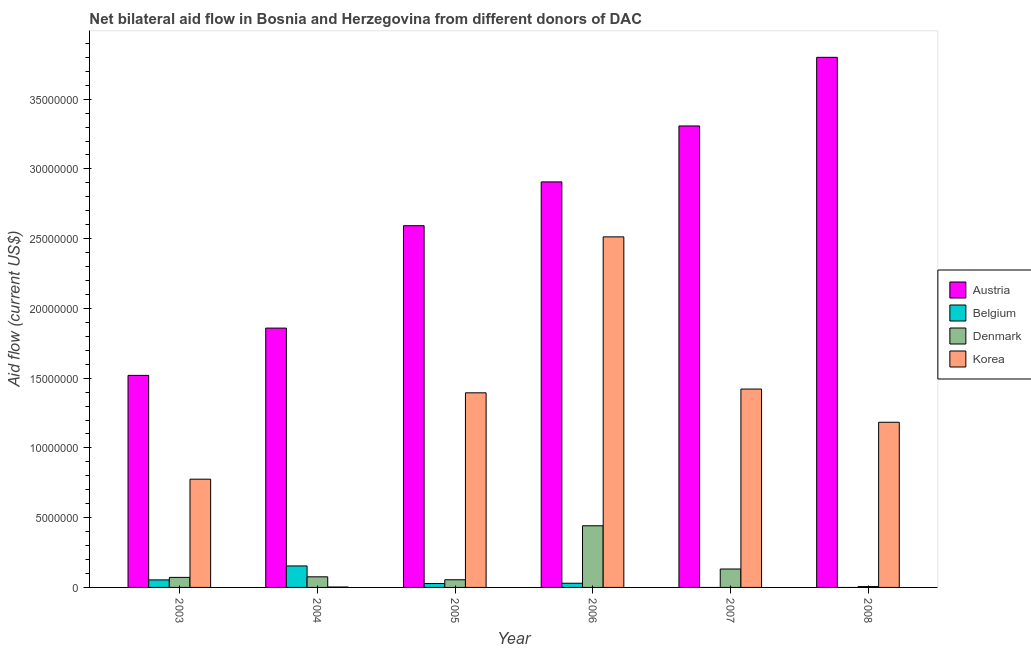How many groups of bars are there?
Make the answer very short. 6. How many bars are there on the 1st tick from the right?
Offer a terse response. 3. In how many cases, is the number of bars for a given year not equal to the number of legend labels?
Give a very brief answer. 2. What is the amount of aid given by belgium in 2005?
Your response must be concise. 2.80e+05. Across all years, what is the maximum amount of aid given by austria?
Ensure brevity in your answer.  3.80e+07. Across all years, what is the minimum amount of aid given by belgium?
Your answer should be very brief. 0. What is the total amount of aid given by korea in the graph?
Provide a succinct answer. 7.29e+07. What is the difference between the amount of aid given by belgium in 2003 and that in 2006?
Offer a terse response. 2.40e+05. What is the difference between the amount of aid given by belgium in 2005 and the amount of aid given by austria in 2004?
Your response must be concise. -1.26e+06. What is the average amount of aid given by belgium per year?
Your answer should be very brief. 4.43e+05. In the year 2006, what is the difference between the amount of aid given by korea and amount of aid given by denmark?
Give a very brief answer. 0. In how many years, is the amount of aid given by austria greater than 8000000 US$?
Make the answer very short. 6. What is the ratio of the amount of aid given by denmark in 2003 to that in 2005?
Keep it short and to the point. 1.31. What is the difference between the highest and the second highest amount of aid given by korea?
Give a very brief answer. 1.09e+07. What is the difference between the highest and the lowest amount of aid given by denmark?
Provide a short and direct response. 4.36e+06. Is it the case that in every year, the sum of the amount of aid given by denmark and amount of aid given by korea is greater than the sum of amount of aid given by austria and amount of aid given by belgium?
Provide a short and direct response. No. How many bars are there?
Offer a very short reply. 22. How many years are there in the graph?
Your response must be concise. 6. Does the graph contain any zero values?
Offer a very short reply. Yes. Does the graph contain grids?
Ensure brevity in your answer.  No. Where does the legend appear in the graph?
Offer a very short reply. Center right. How many legend labels are there?
Offer a terse response. 4. How are the legend labels stacked?
Make the answer very short. Vertical. What is the title of the graph?
Ensure brevity in your answer.  Net bilateral aid flow in Bosnia and Herzegovina from different donors of DAC. What is the label or title of the Y-axis?
Your answer should be very brief. Aid flow (current US$). What is the Aid flow (current US$) in Austria in 2003?
Keep it short and to the point. 1.52e+07. What is the Aid flow (current US$) of Belgium in 2003?
Your response must be concise. 5.40e+05. What is the Aid flow (current US$) in Denmark in 2003?
Provide a succinct answer. 7.20e+05. What is the Aid flow (current US$) of Korea in 2003?
Keep it short and to the point. 7.76e+06. What is the Aid flow (current US$) in Austria in 2004?
Offer a terse response. 1.86e+07. What is the Aid flow (current US$) in Belgium in 2004?
Give a very brief answer. 1.54e+06. What is the Aid flow (current US$) in Denmark in 2004?
Your answer should be compact. 7.60e+05. What is the Aid flow (current US$) of Korea in 2004?
Your response must be concise. 3.00e+04. What is the Aid flow (current US$) in Austria in 2005?
Provide a short and direct response. 2.59e+07. What is the Aid flow (current US$) in Denmark in 2005?
Keep it short and to the point. 5.50e+05. What is the Aid flow (current US$) of Korea in 2005?
Make the answer very short. 1.40e+07. What is the Aid flow (current US$) of Austria in 2006?
Offer a very short reply. 2.91e+07. What is the Aid flow (current US$) in Denmark in 2006?
Your response must be concise. 4.42e+06. What is the Aid flow (current US$) of Korea in 2006?
Offer a terse response. 2.51e+07. What is the Aid flow (current US$) in Austria in 2007?
Make the answer very short. 3.31e+07. What is the Aid flow (current US$) in Belgium in 2007?
Your answer should be very brief. 0. What is the Aid flow (current US$) in Denmark in 2007?
Offer a very short reply. 1.32e+06. What is the Aid flow (current US$) of Korea in 2007?
Your answer should be very brief. 1.42e+07. What is the Aid flow (current US$) of Austria in 2008?
Your answer should be very brief. 3.80e+07. What is the Aid flow (current US$) in Belgium in 2008?
Give a very brief answer. 0. What is the Aid flow (current US$) of Korea in 2008?
Keep it short and to the point. 1.18e+07. Across all years, what is the maximum Aid flow (current US$) of Austria?
Ensure brevity in your answer.  3.80e+07. Across all years, what is the maximum Aid flow (current US$) of Belgium?
Give a very brief answer. 1.54e+06. Across all years, what is the maximum Aid flow (current US$) of Denmark?
Keep it short and to the point. 4.42e+06. Across all years, what is the maximum Aid flow (current US$) of Korea?
Your answer should be compact. 2.51e+07. Across all years, what is the minimum Aid flow (current US$) in Austria?
Your response must be concise. 1.52e+07. Across all years, what is the minimum Aid flow (current US$) in Belgium?
Ensure brevity in your answer.  0. Across all years, what is the minimum Aid flow (current US$) in Denmark?
Provide a succinct answer. 6.00e+04. Across all years, what is the minimum Aid flow (current US$) in Korea?
Provide a short and direct response. 3.00e+04. What is the total Aid flow (current US$) in Austria in the graph?
Provide a succinct answer. 1.60e+08. What is the total Aid flow (current US$) in Belgium in the graph?
Give a very brief answer. 2.66e+06. What is the total Aid flow (current US$) in Denmark in the graph?
Provide a short and direct response. 7.83e+06. What is the total Aid flow (current US$) in Korea in the graph?
Your response must be concise. 7.29e+07. What is the difference between the Aid flow (current US$) of Austria in 2003 and that in 2004?
Make the answer very short. -3.39e+06. What is the difference between the Aid flow (current US$) of Korea in 2003 and that in 2004?
Ensure brevity in your answer.  7.73e+06. What is the difference between the Aid flow (current US$) of Austria in 2003 and that in 2005?
Offer a very short reply. -1.07e+07. What is the difference between the Aid flow (current US$) in Belgium in 2003 and that in 2005?
Offer a terse response. 2.60e+05. What is the difference between the Aid flow (current US$) in Korea in 2003 and that in 2005?
Keep it short and to the point. -6.19e+06. What is the difference between the Aid flow (current US$) of Austria in 2003 and that in 2006?
Offer a very short reply. -1.39e+07. What is the difference between the Aid flow (current US$) of Denmark in 2003 and that in 2006?
Your response must be concise. -3.70e+06. What is the difference between the Aid flow (current US$) of Korea in 2003 and that in 2006?
Provide a short and direct response. -1.74e+07. What is the difference between the Aid flow (current US$) of Austria in 2003 and that in 2007?
Your answer should be compact. -1.79e+07. What is the difference between the Aid flow (current US$) of Denmark in 2003 and that in 2007?
Your answer should be compact. -6.00e+05. What is the difference between the Aid flow (current US$) of Korea in 2003 and that in 2007?
Provide a short and direct response. -6.46e+06. What is the difference between the Aid flow (current US$) in Austria in 2003 and that in 2008?
Give a very brief answer. -2.28e+07. What is the difference between the Aid flow (current US$) of Denmark in 2003 and that in 2008?
Provide a succinct answer. 6.60e+05. What is the difference between the Aid flow (current US$) in Korea in 2003 and that in 2008?
Offer a terse response. -4.08e+06. What is the difference between the Aid flow (current US$) of Austria in 2004 and that in 2005?
Provide a short and direct response. -7.34e+06. What is the difference between the Aid flow (current US$) in Belgium in 2004 and that in 2005?
Ensure brevity in your answer.  1.26e+06. What is the difference between the Aid flow (current US$) of Denmark in 2004 and that in 2005?
Provide a short and direct response. 2.10e+05. What is the difference between the Aid flow (current US$) in Korea in 2004 and that in 2005?
Provide a succinct answer. -1.39e+07. What is the difference between the Aid flow (current US$) in Austria in 2004 and that in 2006?
Keep it short and to the point. -1.05e+07. What is the difference between the Aid flow (current US$) of Belgium in 2004 and that in 2006?
Ensure brevity in your answer.  1.24e+06. What is the difference between the Aid flow (current US$) of Denmark in 2004 and that in 2006?
Provide a short and direct response. -3.66e+06. What is the difference between the Aid flow (current US$) of Korea in 2004 and that in 2006?
Make the answer very short. -2.51e+07. What is the difference between the Aid flow (current US$) of Austria in 2004 and that in 2007?
Give a very brief answer. -1.45e+07. What is the difference between the Aid flow (current US$) of Denmark in 2004 and that in 2007?
Your response must be concise. -5.60e+05. What is the difference between the Aid flow (current US$) in Korea in 2004 and that in 2007?
Offer a very short reply. -1.42e+07. What is the difference between the Aid flow (current US$) in Austria in 2004 and that in 2008?
Offer a very short reply. -1.94e+07. What is the difference between the Aid flow (current US$) in Denmark in 2004 and that in 2008?
Ensure brevity in your answer.  7.00e+05. What is the difference between the Aid flow (current US$) of Korea in 2004 and that in 2008?
Make the answer very short. -1.18e+07. What is the difference between the Aid flow (current US$) in Austria in 2005 and that in 2006?
Your answer should be compact. -3.14e+06. What is the difference between the Aid flow (current US$) of Belgium in 2005 and that in 2006?
Give a very brief answer. -2.00e+04. What is the difference between the Aid flow (current US$) of Denmark in 2005 and that in 2006?
Offer a very short reply. -3.87e+06. What is the difference between the Aid flow (current US$) of Korea in 2005 and that in 2006?
Offer a terse response. -1.12e+07. What is the difference between the Aid flow (current US$) of Austria in 2005 and that in 2007?
Your response must be concise. -7.15e+06. What is the difference between the Aid flow (current US$) of Denmark in 2005 and that in 2007?
Ensure brevity in your answer.  -7.70e+05. What is the difference between the Aid flow (current US$) of Korea in 2005 and that in 2007?
Provide a succinct answer. -2.70e+05. What is the difference between the Aid flow (current US$) in Austria in 2005 and that in 2008?
Offer a very short reply. -1.21e+07. What is the difference between the Aid flow (current US$) in Denmark in 2005 and that in 2008?
Ensure brevity in your answer.  4.90e+05. What is the difference between the Aid flow (current US$) in Korea in 2005 and that in 2008?
Give a very brief answer. 2.11e+06. What is the difference between the Aid flow (current US$) of Austria in 2006 and that in 2007?
Your answer should be compact. -4.01e+06. What is the difference between the Aid flow (current US$) in Denmark in 2006 and that in 2007?
Offer a terse response. 3.10e+06. What is the difference between the Aid flow (current US$) in Korea in 2006 and that in 2007?
Keep it short and to the point. 1.09e+07. What is the difference between the Aid flow (current US$) in Austria in 2006 and that in 2008?
Your response must be concise. -8.93e+06. What is the difference between the Aid flow (current US$) in Denmark in 2006 and that in 2008?
Offer a terse response. 4.36e+06. What is the difference between the Aid flow (current US$) in Korea in 2006 and that in 2008?
Ensure brevity in your answer.  1.33e+07. What is the difference between the Aid flow (current US$) of Austria in 2007 and that in 2008?
Offer a terse response. -4.92e+06. What is the difference between the Aid flow (current US$) in Denmark in 2007 and that in 2008?
Provide a succinct answer. 1.26e+06. What is the difference between the Aid flow (current US$) in Korea in 2007 and that in 2008?
Your answer should be compact. 2.38e+06. What is the difference between the Aid flow (current US$) in Austria in 2003 and the Aid flow (current US$) in Belgium in 2004?
Your answer should be compact. 1.37e+07. What is the difference between the Aid flow (current US$) in Austria in 2003 and the Aid flow (current US$) in Denmark in 2004?
Ensure brevity in your answer.  1.44e+07. What is the difference between the Aid flow (current US$) of Austria in 2003 and the Aid flow (current US$) of Korea in 2004?
Offer a terse response. 1.52e+07. What is the difference between the Aid flow (current US$) in Belgium in 2003 and the Aid flow (current US$) in Korea in 2004?
Give a very brief answer. 5.10e+05. What is the difference between the Aid flow (current US$) of Denmark in 2003 and the Aid flow (current US$) of Korea in 2004?
Make the answer very short. 6.90e+05. What is the difference between the Aid flow (current US$) of Austria in 2003 and the Aid flow (current US$) of Belgium in 2005?
Ensure brevity in your answer.  1.49e+07. What is the difference between the Aid flow (current US$) in Austria in 2003 and the Aid flow (current US$) in Denmark in 2005?
Keep it short and to the point. 1.46e+07. What is the difference between the Aid flow (current US$) of Austria in 2003 and the Aid flow (current US$) of Korea in 2005?
Provide a short and direct response. 1.25e+06. What is the difference between the Aid flow (current US$) of Belgium in 2003 and the Aid flow (current US$) of Denmark in 2005?
Give a very brief answer. -10000. What is the difference between the Aid flow (current US$) in Belgium in 2003 and the Aid flow (current US$) in Korea in 2005?
Give a very brief answer. -1.34e+07. What is the difference between the Aid flow (current US$) in Denmark in 2003 and the Aid flow (current US$) in Korea in 2005?
Offer a terse response. -1.32e+07. What is the difference between the Aid flow (current US$) in Austria in 2003 and the Aid flow (current US$) in Belgium in 2006?
Keep it short and to the point. 1.49e+07. What is the difference between the Aid flow (current US$) in Austria in 2003 and the Aid flow (current US$) in Denmark in 2006?
Make the answer very short. 1.08e+07. What is the difference between the Aid flow (current US$) in Austria in 2003 and the Aid flow (current US$) in Korea in 2006?
Offer a terse response. -9.93e+06. What is the difference between the Aid flow (current US$) of Belgium in 2003 and the Aid flow (current US$) of Denmark in 2006?
Provide a succinct answer. -3.88e+06. What is the difference between the Aid flow (current US$) of Belgium in 2003 and the Aid flow (current US$) of Korea in 2006?
Make the answer very short. -2.46e+07. What is the difference between the Aid flow (current US$) of Denmark in 2003 and the Aid flow (current US$) of Korea in 2006?
Your answer should be very brief. -2.44e+07. What is the difference between the Aid flow (current US$) of Austria in 2003 and the Aid flow (current US$) of Denmark in 2007?
Provide a succinct answer. 1.39e+07. What is the difference between the Aid flow (current US$) in Austria in 2003 and the Aid flow (current US$) in Korea in 2007?
Give a very brief answer. 9.80e+05. What is the difference between the Aid flow (current US$) in Belgium in 2003 and the Aid flow (current US$) in Denmark in 2007?
Your answer should be very brief. -7.80e+05. What is the difference between the Aid flow (current US$) of Belgium in 2003 and the Aid flow (current US$) of Korea in 2007?
Your response must be concise. -1.37e+07. What is the difference between the Aid flow (current US$) of Denmark in 2003 and the Aid flow (current US$) of Korea in 2007?
Offer a very short reply. -1.35e+07. What is the difference between the Aid flow (current US$) in Austria in 2003 and the Aid flow (current US$) in Denmark in 2008?
Offer a terse response. 1.51e+07. What is the difference between the Aid flow (current US$) of Austria in 2003 and the Aid flow (current US$) of Korea in 2008?
Give a very brief answer. 3.36e+06. What is the difference between the Aid flow (current US$) of Belgium in 2003 and the Aid flow (current US$) of Denmark in 2008?
Provide a succinct answer. 4.80e+05. What is the difference between the Aid flow (current US$) in Belgium in 2003 and the Aid flow (current US$) in Korea in 2008?
Make the answer very short. -1.13e+07. What is the difference between the Aid flow (current US$) in Denmark in 2003 and the Aid flow (current US$) in Korea in 2008?
Provide a succinct answer. -1.11e+07. What is the difference between the Aid flow (current US$) in Austria in 2004 and the Aid flow (current US$) in Belgium in 2005?
Give a very brief answer. 1.83e+07. What is the difference between the Aid flow (current US$) in Austria in 2004 and the Aid flow (current US$) in Denmark in 2005?
Ensure brevity in your answer.  1.80e+07. What is the difference between the Aid flow (current US$) of Austria in 2004 and the Aid flow (current US$) of Korea in 2005?
Give a very brief answer. 4.64e+06. What is the difference between the Aid flow (current US$) in Belgium in 2004 and the Aid flow (current US$) in Denmark in 2005?
Offer a very short reply. 9.90e+05. What is the difference between the Aid flow (current US$) in Belgium in 2004 and the Aid flow (current US$) in Korea in 2005?
Ensure brevity in your answer.  -1.24e+07. What is the difference between the Aid flow (current US$) in Denmark in 2004 and the Aid flow (current US$) in Korea in 2005?
Give a very brief answer. -1.32e+07. What is the difference between the Aid flow (current US$) in Austria in 2004 and the Aid flow (current US$) in Belgium in 2006?
Offer a terse response. 1.83e+07. What is the difference between the Aid flow (current US$) in Austria in 2004 and the Aid flow (current US$) in Denmark in 2006?
Ensure brevity in your answer.  1.42e+07. What is the difference between the Aid flow (current US$) of Austria in 2004 and the Aid flow (current US$) of Korea in 2006?
Keep it short and to the point. -6.54e+06. What is the difference between the Aid flow (current US$) of Belgium in 2004 and the Aid flow (current US$) of Denmark in 2006?
Provide a short and direct response. -2.88e+06. What is the difference between the Aid flow (current US$) of Belgium in 2004 and the Aid flow (current US$) of Korea in 2006?
Make the answer very short. -2.36e+07. What is the difference between the Aid flow (current US$) of Denmark in 2004 and the Aid flow (current US$) of Korea in 2006?
Keep it short and to the point. -2.44e+07. What is the difference between the Aid flow (current US$) in Austria in 2004 and the Aid flow (current US$) in Denmark in 2007?
Your answer should be very brief. 1.73e+07. What is the difference between the Aid flow (current US$) of Austria in 2004 and the Aid flow (current US$) of Korea in 2007?
Offer a very short reply. 4.37e+06. What is the difference between the Aid flow (current US$) of Belgium in 2004 and the Aid flow (current US$) of Korea in 2007?
Make the answer very short. -1.27e+07. What is the difference between the Aid flow (current US$) of Denmark in 2004 and the Aid flow (current US$) of Korea in 2007?
Offer a very short reply. -1.35e+07. What is the difference between the Aid flow (current US$) of Austria in 2004 and the Aid flow (current US$) of Denmark in 2008?
Give a very brief answer. 1.85e+07. What is the difference between the Aid flow (current US$) of Austria in 2004 and the Aid flow (current US$) of Korea in 2008?
Keep it short and to the point. 6.75e+06. What is the difference between the Aid flow (current US$) of Belgium in 2004 and the Aid flow (current US$) of Denmark in 2008?
Provide a succinct answer. 1.48e+06. What is the difference between the Aid flow (current US$) in Belgium in 2004 and the Aid flow (current US$) in Korea in 2008?
Offer a terse response. -1.03e+07. What is the difference between the Aid flow (current US$) in Denmark in 2004 and the Aid flow (current US$) in Korea in 2008?
Your response must be concise. -1.11e+07. What is the difference between the Aid flow (current US$) of Austria in 2005 and the Aid flow (current US$) of Belgium in 2006?
Ensure brevity in your answer.  2.56e+07. What is the difference between the Aid flow (current US$) of Austria in 2005 and the Aid flow (current US$) of Denmark in 2006?
Your response must be concise. 2.15e+07. What is the difference between the Aid flow (current US$) of Belgium in 2005 and the Aid flow (current US$) of Denmark in 2006?
Make the answer very short. -4.14e+06. What is the difference between the Aid flow (current US$) in Belgium in 2005 and the Aid flow (current US$) in Korea in 2006?
Offer a very short reply. -2.48e+07. What is the difference between the Aid flow (current US$) of Denmark in 2005 and the Aid flow (current US$) of Korea in 2006?
Provide a succinct answer. -2.46e+07. What is the difference between the Aid flow (current US$) in Austria in 2005 and the Aid flow (current US$) in Denmark in 2007?
Keep it short and to the point. 2.46e+07. What is the difference between the Aid flow (current US$) of Austria in 2005 and the Aid flow (current US$) of Korea in 2007?
Your answer should be very brief. 1.17e+07. What is the difference between the Aid flow (current US$) in Belgium in 2005 and the Aid flow (current US$) in Denmark in 2007?
Your answer should be compact. -1.04e+06. What is the difference between the Aid flow (current US$) in Belgium in 2005 and the Aid flow (current US$) in Korea in 2007?
Offer a terse response. -1.39e+07. What is the difference between the Aid flow (current US$) in Denmark in 2005 and the Aid flow (current US$) in Korea in 2007?
Provide a succinct answer. -1.37e+07. What is the difference between the Aid flow (current US$) of Austria in 2005 and the Aid flow (current US$) of Denmark in 2008?
Offer a very short reply. 2.59e+07. What is the difference between the Aid flow (current US$) in Austria in 2005 and the Aid flow (current US$) in Korea in 2008?
Offer a very short reply. 1.41e+07. What is the difference between the Aid flow (current US$) in Belgium in 2005 and the Aid flow (current US$) in Denmark in 2008?
Provide a succinct answer. 2.20e+05. What is the difference between the Aid flow (current US$) of Belgium in 2005 and the Aid flow (current US$) of Korea in 2008?
Your response must be concise. -1.16e+07. What is the difference between the Aid flow (current US$) in Denmark in 2005 and the Aid flow (current US$) in Korea in 2008?
Keep it short and to the point. -1.13e+07. What is the difference between the Aid flow (current US$) of Austria in 2006 and the Aid flow (current US$) of Denmark in 2007?
Make the answer very short. 2.78e+07. What is the difference between the Aid flow (current US$) in Austria in 2006 and the Aid flow (current US$) in Korea in 2007?
Your answer should be very brief. 1.48e+07. What is the difference between the Aid flow (current US$) of Belgium in 2006 and the Aid flow (current US$) of Denmark in 2007?
Offer a terse response. -1.02e+06. What is the difference between the Aid flow (current US$) in Belgium in 2006 and the Aid flow (current US$) in Korea in 2007?
Your answer should be compact. -1.39e+07. What is the difference between the Aid flow (current US$) in Denmark in 2006 and the Aid flow (current US$) in Korea in 2007?
Keep it short and to the point. -9.80e+06. What is the difference between the Aid flow (current US$) in Austria in 2006 and the Aid flow (current US$) in Denmark in 2008?
Offer a terse response. 2.90e+07. What is the difference between the Aid flow (current US$) of Austria in 2006 and the Aid flow (current US$) of Korea in 2008?
Ensure brevity in your answer.  1.72e+07. What is the difference between the Aid flow (current US$) of Belgium in 2006 and the Aid flow (current US$) of Korea in 2008?
Offer a terse response. -1.15e+07. What is the difference between the Aid flow (current US$) of Denmark in 2006 and the Aid flow (current US$) of Korea in 2008?
Offer a very short reply. -7.42e+06. What is the difference between the Aid flow (current US$) in Austria in 2007 and the Aid flow (current US$) in Denmark in 2008?
Keep it short and to the point. 3.30e+07. What is the difference between the Aid flow (current US$) in Austria in 2007 and the Aid flow (current US$) in Korea in 2008?
Provide a succinct answer. 2.12e+07. What is the difference between the Aid flow (current US$) of Denmark in 2007 and the Aid flow (current US$) of Korea in 2008?
Give a very brief answer. -1.05e+07. What is the average Aid flow (current US$) in Austria per year?
Offer a terse response. 2.66e+07. What is the average Aid flow (current US$) of Belgium per year?
Provide a succinct answer. 4.43e+05. What is the average Aid flow (current US$) of Denmark per year?
Your answer should be very brief. 1.30e+06. What is the average Aid flow (current US$) of Korea per year?
Your answer should be very brief. 1.22e+07. In the year 2003, what is the difference between the Aid flow (current US$) in Austria and Aid flow (current US$) in Belgium?
Your answer should be very brief. 1.47e+07. In the year 2003, what is the difference between the Aid flow (current US$) of Austria and Aid flow (current US$) of Denmark?
Provide a short and direct response. 1.45e+07. In the year 2003, what is the difference between the Aid flow (current US$) of Austria and Aid flow (current US$) of Korea?
Provide a succinct answer. 7.44e+06. In the year 2003, what is the difference between the Aid flow (current US$) of Belgium and Aid flow (current US$) of Korea?
Offer a terse response. -7.22e+06. In the year 2003, what is the difference between the Aid flow (current US$) in Denmark and Aid flow (current US$) in Korea?
Your response must be concise. -7.04e+06. In the year 2004, what is the difference between the Aid flow (current US$) of Austria and Aid flow (current US$) of Belgium?
Ensure brevity in your answer.  1.70e+07. In the year 2004, what is the difference between the Aid flow (current US$) of Austria and Aid flow (current US$) of Denmark?
Offer a terse response. 1.78e+07. In the year 2004, what is the difference between the Aid flow (current US$) in Austria and Aid flow (current US$) in Korea?
Your answer should be compact. 1.86e+07. In the year 2004, what is the difference between the Aid flow (current US$) in Belgium and Aid flow (current US$) in Denmark?
Offer a terse response. 7.80e+05. In the year 2004, what is the difference between the Aid flow (current US$) in Belgium and Aid flow (current US$) in Korea?
Ensure brevity in your answer.  1.51e+06. In the year 2004, what is the difference between the Aid flow (current US$) of Denmark and Aid flow (current US$) of Korea?
Ensure brevity in your answer.  7.30e+05. In the year 2005, what is the difference between the Aid flow (current US$) of Austria and Aid flow (current US$) of Belgium?
Offer a terse response. 2.56e+07. In the year 2005, what is the difference between the Aid flow (current US$) in Austria and Aid flow (current US$) in Denmark?
Your answer should be compact. 2.54e+07. In the year 2005, what is the difference between the Aid flow (current US$) of Austria and Aid flow (current US$) of Korea?
Your response must be concise. 1.20e+07. In the year 2005, what is the difference between the Aid flow (current US$) in Belgium and Aid flow (current US$) in Denmark?
Provide a succinct answer. -2.70e+05. In the year 2005, what is the difference between the Aid flow (current US$) of Belgium and Aid flow (current US$) of Korea?
Keep it short and to the point. -1.37e+07. In the year 2005, what is the difference between the Aid flow (current US$) of Denmark and Aid flow (current US$) of Korea?
Your answer should be very brief. -1.34e+07. In the year 2006, what is the difference between the Aid flow (current US$) of Austria and Aid flow (current US$) of Belgium?
Your answer should be compact. 2.88e+07. In the year 2006, what is the difference between the Aid flow (current US$) of Austria and Aid flow (current US$) of Denmark?
Make the answer very short. 2.46e+07. In the year 2006, what is the difference between the Aid flow (current US$) in Austria and Aid flow (current US$) in Korea?
Offer a very short reply. 3.94e+06. In the year 2006, what is the difference between the Aid flow (current US$) in Belgium and Aid flow (current US$) in Denmark?
Your answer should be compact. -4.12e+06. In the year 2006, what is the difference between the Aid flow (current US$) in Belgium and Aid flow (current US$) in Korea?
Keep it short and to the point. -2.48e+07. In the year 2006, what is the difference between the Aid flow (current US$) of Denmark and Aid flow (current US$) of Korea?
Provide a short and direct response. -2.07e+07. In the year 2007, what is the difference between the Aid flow (current US$) of Austria and Aid flow (current US$) of Denmark?
Offer a very short reply. 3.18e+07. In the year 2007, what is the difference between the Aid flow (current US$) in Austria and Aid flow (current US$) in Korea?
Your answer should be compact. 1.89e+07. In the year 2007, what is the difference between the Aid flow (current US$) of Denmark and Aid flow (current US$) of Korea?
Give a very brief answer. -1.29e+07. In the year 2008, what is the difference between the Aid flow (current US$) of Austria and Aid flow (current US$) of Denmark?
Your response must be concise. 3.79e+07. In the year 2008, what is the difference between the Aid flow (current US$) in Austria and Aid flow (current US$) in Korea?
Offer a very short reply. 2.62e+07. In the year 2008, what is the difference between the Aid flow (current US$) in Denmark and Aid flow (current US$) in Korea?
Your answer should be very brief. -1.18e+07. What is the ratio of the Aid flow (current US$) in Austria in 2003 to that in 2004?
Offer a terse response. 0.82. What is the ratio of the Aid flow (current US$) of Belgium in 2003 to that in 2004?
Provide a succinct answer. 0.35. What is the ratio of the Aid flow (current US$) of Korea in 2003 to that in 2004?
Keep it short and to the point. 258.67. What is the ratio of the Aid flow (current US$) of Austria in 2003 to that in 2005?
Your answer should be very brief. 0.59. What is the ratio of the Aid flow (current US$) in Belgium in 2003 to that in 2005?
Give a very brief answer. 1.93. What is the ratio of the Aid flow (current US$) of Denmark in 2003 to that in 2005?
Your response must be concise. 1.31. What is the ratio of the Aid flow (current US$) of Korea in 2003 to that in 2005?
Ensure brevity in your answer.  0.56. What is the ratio of the Aid flow (current US$) in Austria in 2003 to that in 2006?
Make the answer very short. 0.52. What is the ratio of the Aid flow (current US$) in Belgium in 2003 to that in 2006?
Offer a terse response. 1.8. What is the ratio of the Aid flow (current US$) in Denmark in 2003 to that in 2006?
Ensure brevity in your answer.  0.16. What is the ratio of the Aid flow (current US$) of Korea in 2003 to that in 2006?
Your response must be concise. 0.31. What is the ratio of the Aid flow (current US$) in Austria in 2003 to that in 2007?
Your answer should be compact. 0.46. What is the ratio of the Aid flow (current US$) of Denmark in 2003 to that in 2007?
Provide a short and direct response. 0.55. What is the ratio of the Aid flow (current US$) of Korea in 2003 to that in 2007?
Keep it short and to the point. 0.55. What is the ratio of the Aid flow (current US$) in Denmark in 2003 to that in 2008?
Make the answer very short. 12. What is the ratio of the Aid flow (current US$) in Korea in 2003 to that in 2008?
Offer a very short reply. 0.66. What is the ratio of the Aid flow (current US$) of Austria in 2004 to that in 2005?
Offer a terse response. 0.72. What is the ratio of the Aid flow (current US$) in Denmark in 2004 to that in 2005?
Provide a succinct answer. 1.38. What is the ratio of the Aid flow (current US$) in Korea in 2004 to that in 2005?
Your answer should be very brief. 0. What is the ratio of the Aid flow (current US$) in Austria in 2004 to that in 2006?
Provide a succinct answer. 0.64. What is the ratio of the Aid flow (current US$) in Belgium in 2004 to that in 2006?
Ensure brevity in your answer.  5.13. What is the ratio of the Aid flow (current US$) of Denmark in 2004 to that in 2006?
Your answer should be very brief. 0.17. What is the ratio of the Aid flow (current US$) in Korea in 2004 to that in 2006?
Provide a short and direct response. 0. What is the ratio of the Aid flow (current US$) of Austria in 2004 to that in 2007?
Your answer should be compact. 0.56. What is the ratio of the Aid flow (current US$) in Denmark in 2004 to that in 2007?
Provide a succinct answer. 0.58. What is the ratio of the Aid flow (current US$) in Korea in 2004 to that in 2007?
Offer a very short reply. 0. What is the ratio of the Aid flow (current US$) in Austria in 2004 to that in 2008?
Your answer should be compact. 0.49. What is the ratio of the Aid flow (current US$) in Denmark in 2004 to that in 2008?
Give a very brief answer. 12.67. What is the ratio of the Aid flow (current US$) in Korea in 2004 to that in 2008?
Offer a terse response. 0. What is the ratio of the Aid flow (current US$) in Austria in 2005 to that in 2006?
Your answer should be very brief. 0.89. What is the ratio of the Aid flow (current US$) of Denmark in 2005 to that in 2006?
Make the answer very short. 0.12. What is the ratio of the Aid flow (current US$) of Korea in 2005 to that in 2006?
Provide a short and direct response. 0.56. What is the ratio of the Aid flow (current US$) of Austria in 2005 to that in 2007?
Provide a succinct answer. 0.78. What is the ratio of the Aid flow (current US$) in Denmark in 2005 to that in 2007?
Keep it short and to the point. 0.42. What is the ratio of the Aid flow (current US$) of Austria in 2005 to that in 2008?
Provide a succinct answer. 0.68. What is the ratio of the Aid flow (current US$) of Denmark in 2005 to that in 2008?
Keep it short and to the point. 9.17. What is the ratio of the Aid flow (current US$) of Korea in 2005 to that in 2008?
Offer a terse response. 1.18. What is the ratio of the Aid flow (current US$) in Austria in 2006 to that in 2007?
Provide a short and direct response. 0.88. What is the ratio of the Aid flow (current US$) of Denmark in 2006 to that in 2007?
Provide a short and direct response. 3.35. What is the ratio of the Aid flow (current US$) of Korea in 2006 to that in 2007?
Provide a succinct answer. 1.77. What is the ratio of the Aid flow (current US$) in Austria in 2006 to that in 2008?
Offer a very short reply. 0.77. What is the ratio of the Aid flow (current US$) of Denmark in 2006 to that in 2008?
Your response must be concise. 73.67. What is the ratio of the Aid flow (current US$) of Korea in 2006 to that in 2008?
Ensure brevity in your answer.  2.12. What is the ratio of the Aid flow (current US$) of Austria in 2007 to that in 2008?
Ensure brevity in your answer.  0.87. What is the ratio of the Aid flow (current US$) of Korea in 2007 to that in 2008?
Keep it short and to the point. 1.2. What is the difference between the highest and the second highest Aid flow (current US$) of Austria?
Ensure brevity in your answer.  4.92e+06. What is the difference between the highest and the second highest Aid flow (current US$) of Denmark?
Make the answer very short. 3.10e+06. What is the difference between the highest and the second highest Aid flow (current US$) of Korea?
Your response must be concise. 1.09e+07. What is the difference between the highest and the lowest Aid flow (current US$) in Austria?
Make the answer very short. 2.28e+07. What is the difference between the highest and the lowest Aid flow (current US$) in Belgium?
Your answer should be compact. 1.54e+06. What is the difference between the highest and the lowest Aid flow (current US$) in Denmark?
Keep it short and to the point. 4.36e+06. What is the difference between the highest and the lowest Aid flow (current US$) of Korea?
Make the answer very short. 2.51e+07. 